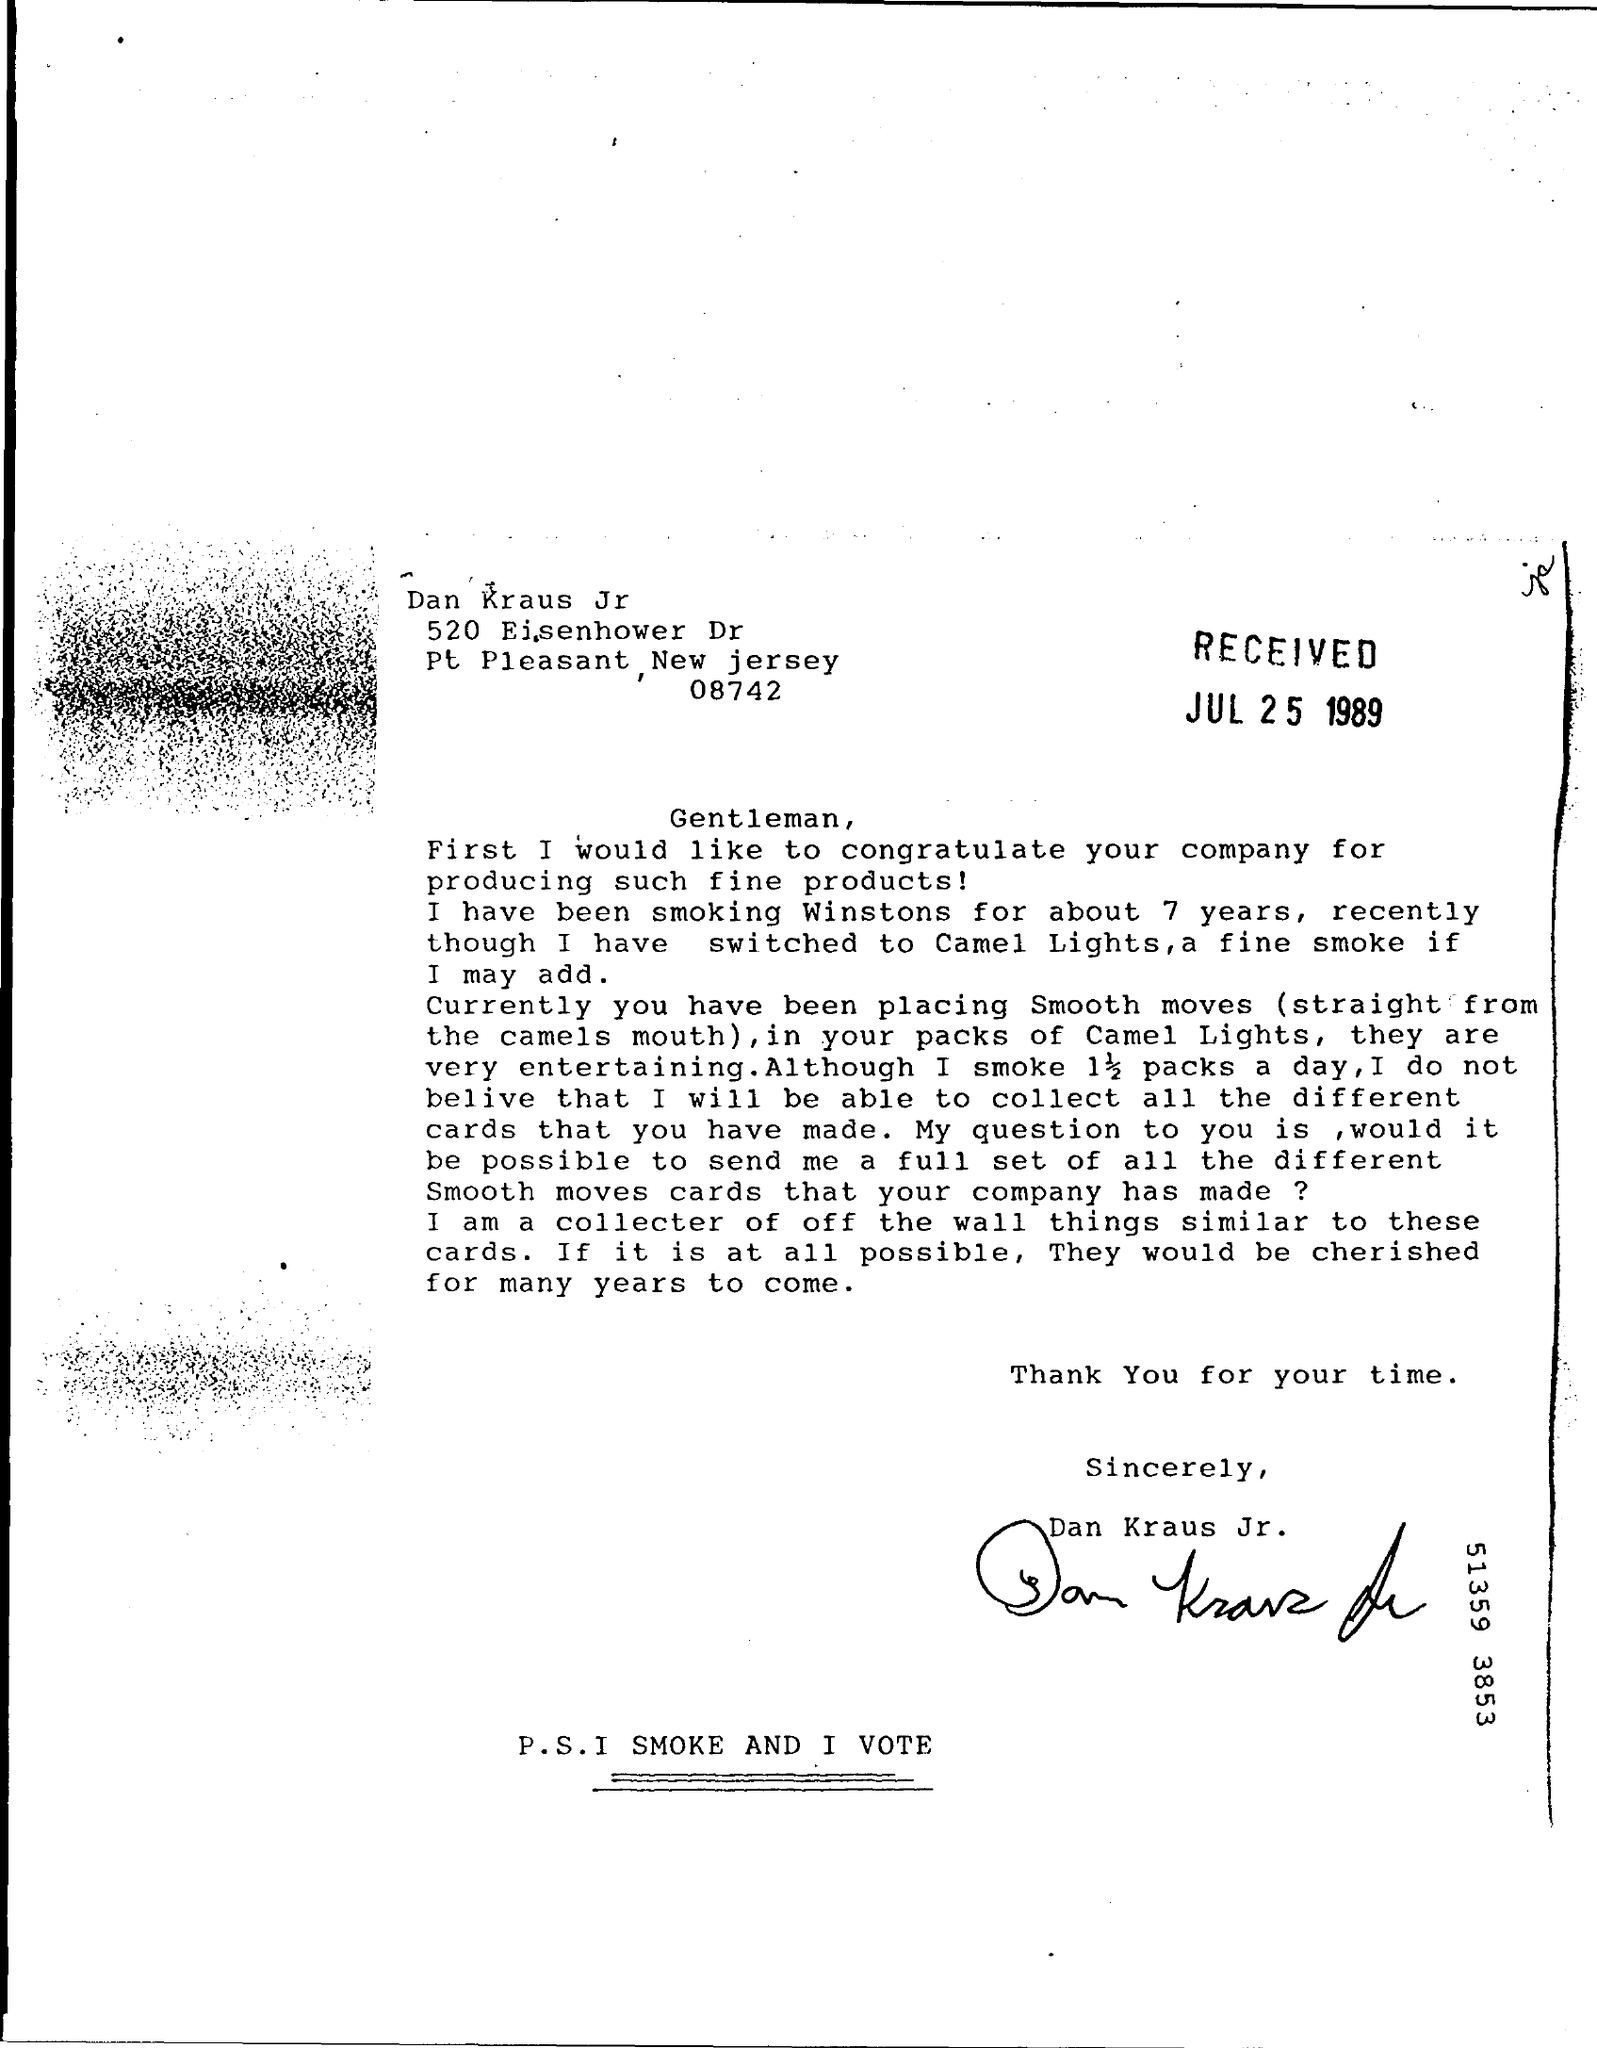On which date this letter was received ?
Provide a short and direct response. JUL 25 1989. Who's sign was there at the end of the letter ?
Ensure brevity in your answer.  Dan Kraus Jr. 